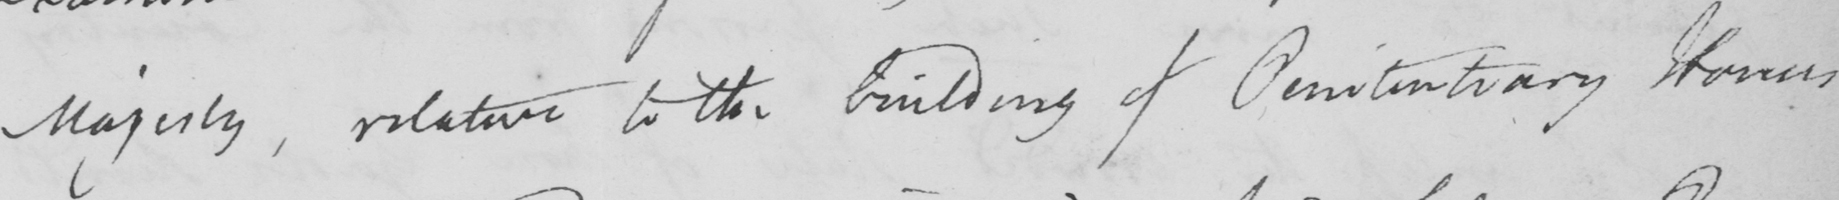Please transcribe the handwritten text in this image. Majesty, relative to the building of Penitentiary Houses 